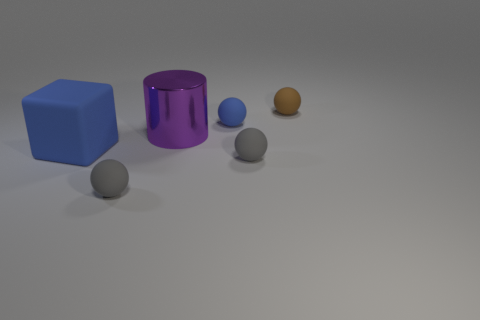Subtract all blue spheres. How many spheres are left? 3 Subtract all purple blocks. How many gray spheres are left? 2 Add 1 big red matte cylinders. How many objects exist? 7 Subtract all brown spheres. How many spheres are left? 3 Subtract all cylinders. How many objects are left? 5 Subtract all yellow balls. Subtract all brown cylinders. How many balls are left? 4 Subtract all spheres. Subtract all tiny blue spheres. How many objects are left? 1 Add 5 big shiny cylinders. How many big shiny cylinders are left? 6 Add 4 small gray rubber balls. How many small gray rubber balls exist? 6 Subtract 1 blue spheres. How many objects are left? 5 